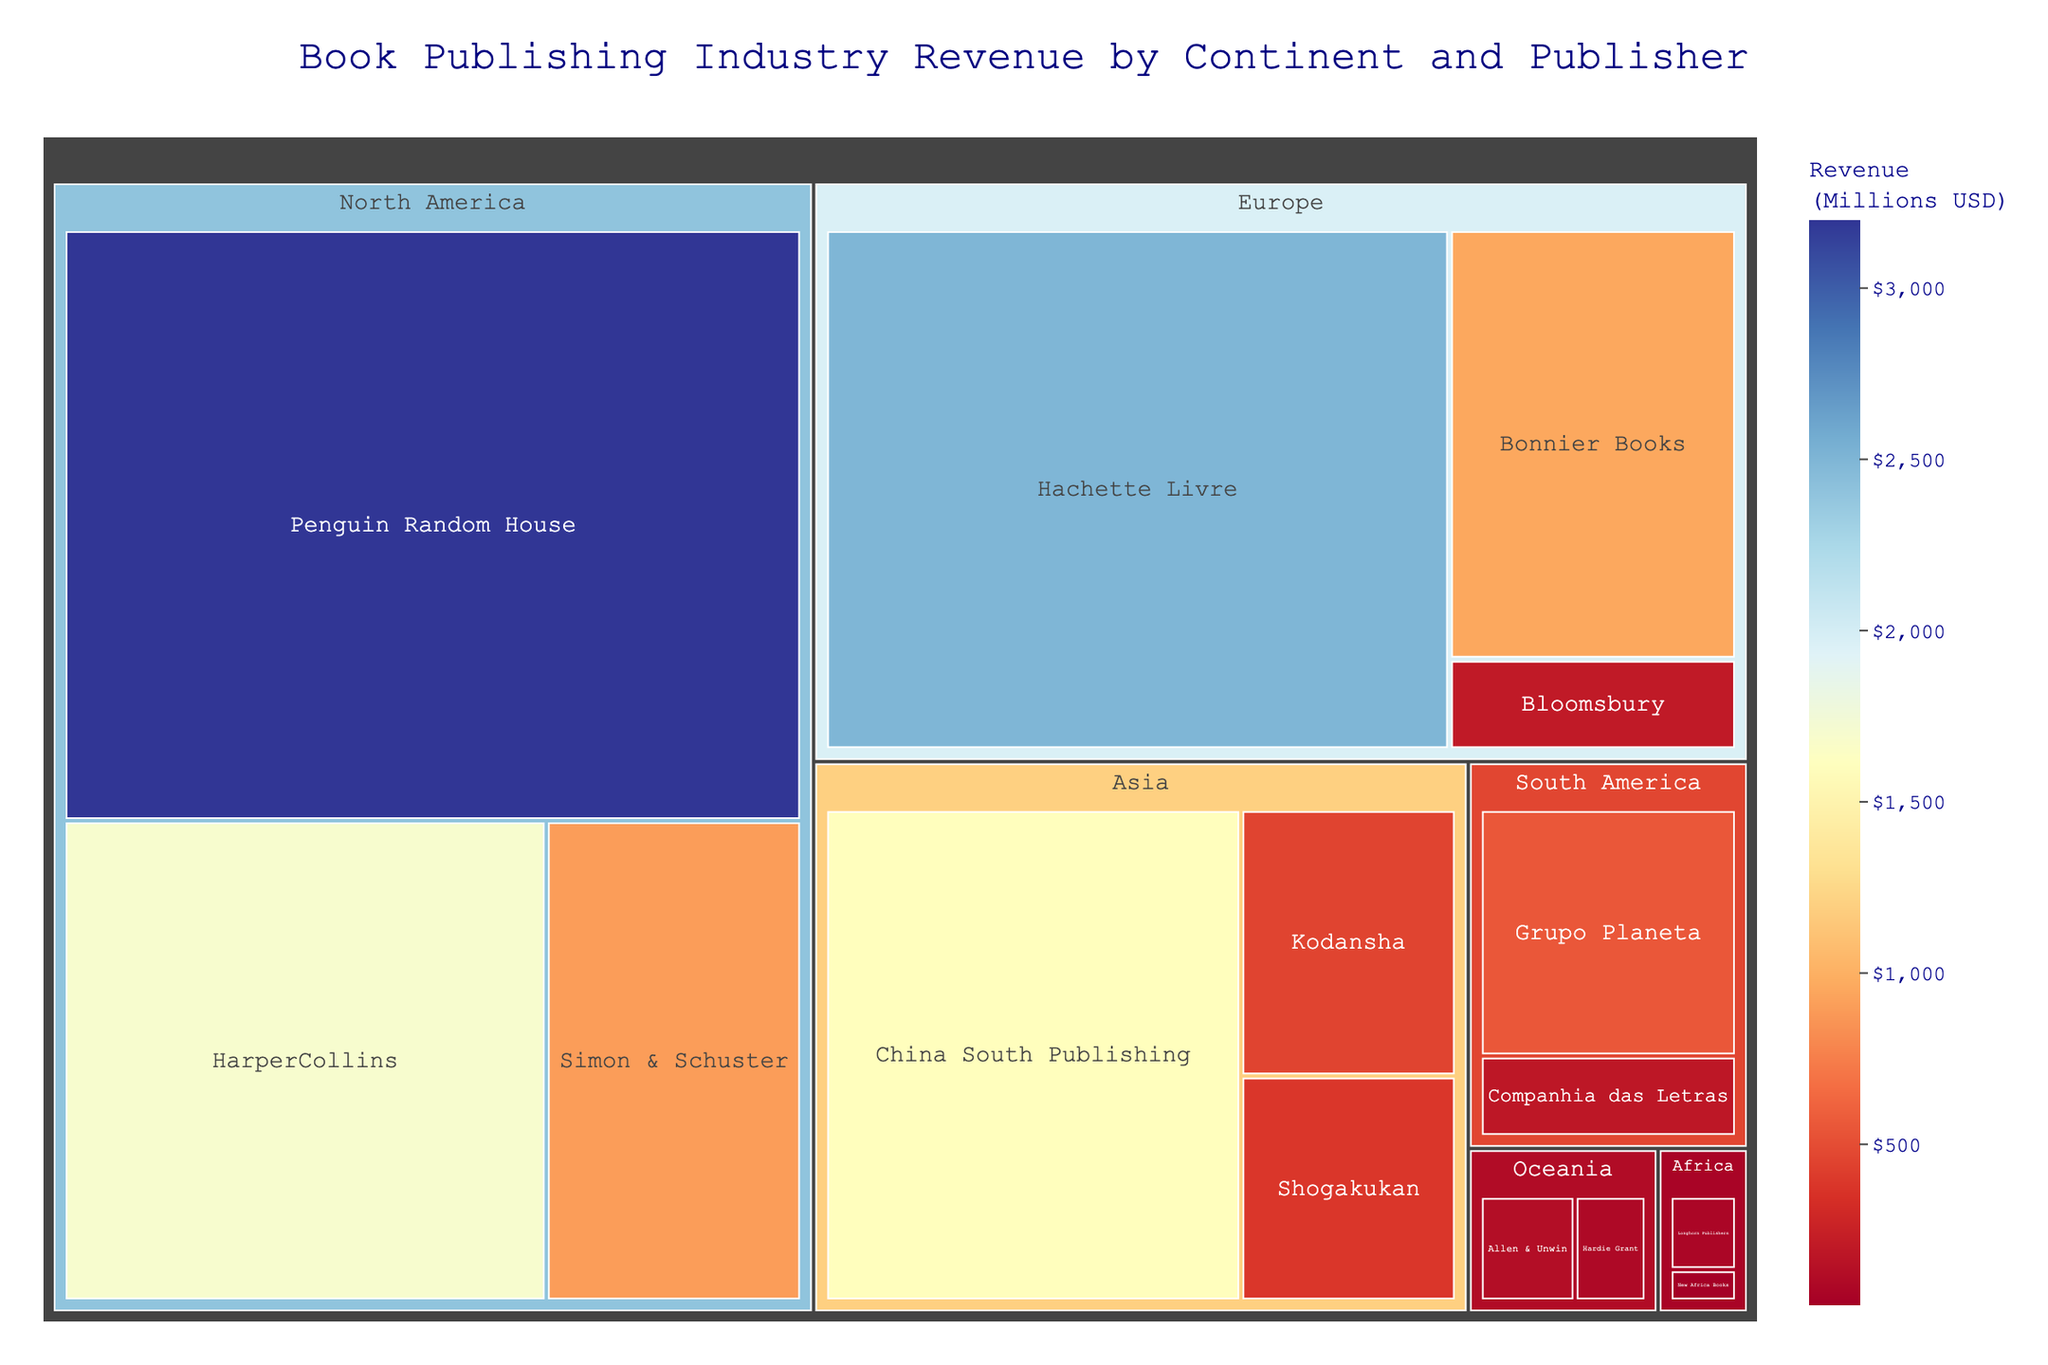How many continents are represented in the treemap? Look at the different sections in the treemap labeled by continent. Count the unique continents.
Answer: 6 Which continent has the highest revenue from the book publishing industry? Observe the size and color intensity of the segments representing each continent. The largest segment with the most intense color often indicates the highest revenue.
Answer: North America Which publisher in Europe has the highest revenue? Find the European section in the treemap, then identify the publisher with the largest segment and the most intense color within this section.
Answer: Hachette Livre What is the total revenue of publishers in Asia? Sum the revenues of all publishers listed under the Asia section. 1600 (China South Publishing) + 450 (Kodansha) + 380 (Shogakukan) = 2430
Answer: 2430 Is the revenue of Longhorn Publishers higher than New Africa Books? Compare the sizes and colors of the segments representing Longhorn Publishers and New Africa Books in the Africa section.
Answer: Yes What is the difference in revenue between Penguin Random House and HarperCollins? Subtract the revenue of HarperCollins from Penguin Random House. 3200 - 1700 = 1500
Answer: 1500 Which publisher has the smallest revenue in the dataset? Identify the smallest segment with the least intense color in the entire treemap.
Answer: New Africa Books Is the combined revenue of publishers in Oceania greater than Grupo Planeta's revenue? Sum the revenues of Allen & Unwin and Hardie Grant (120 + 90 = 210) and compare it with Grupo Planeta's revenue (550).
Answer: No How many publishers are listed in North America? Count the individual segments representing publishers within the North America section of the treemap.
Answer: 3 Between Grupo Planeta and Companhia das Letras, which has a higher revenue? Compare the revenue values given for Grupo Planeta and Companhia das Letras in the South America section.
Answer: Grupo Planeta 